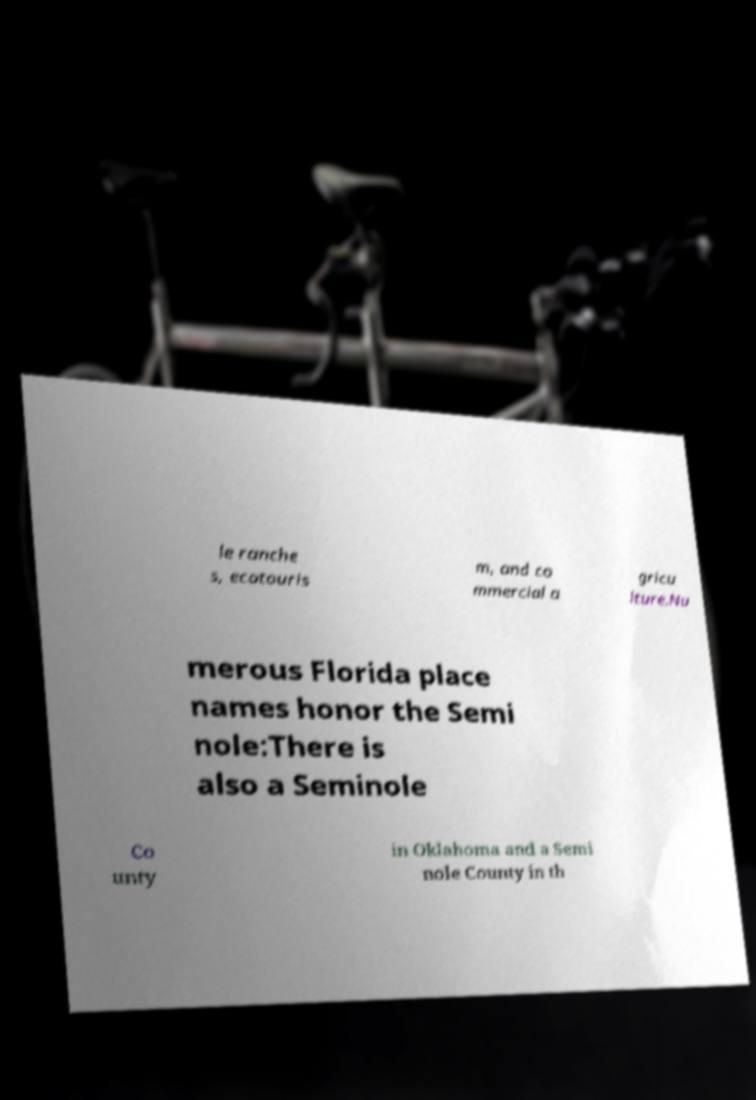Can you read and provide the text displayed in the image?This photo seems to have some interesting text. Can you extract and type it out for me? le ranche s, ecotouris m, and co mmercial a gricu lture.Nu merous Florida place names honor the Semi nole:There is also a Seminole Co unty in Oklahoma and a Semi nole County in th 